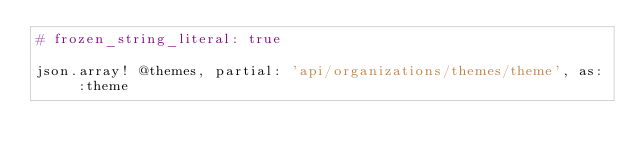Convert code to text. <code><loc_0><loc_0><loc_500><loc_500><_Ruby_># frozen_string_literal: true

json.array! @themes, partial: 'api/organizations/themes/theme', as: :theme
</code> 